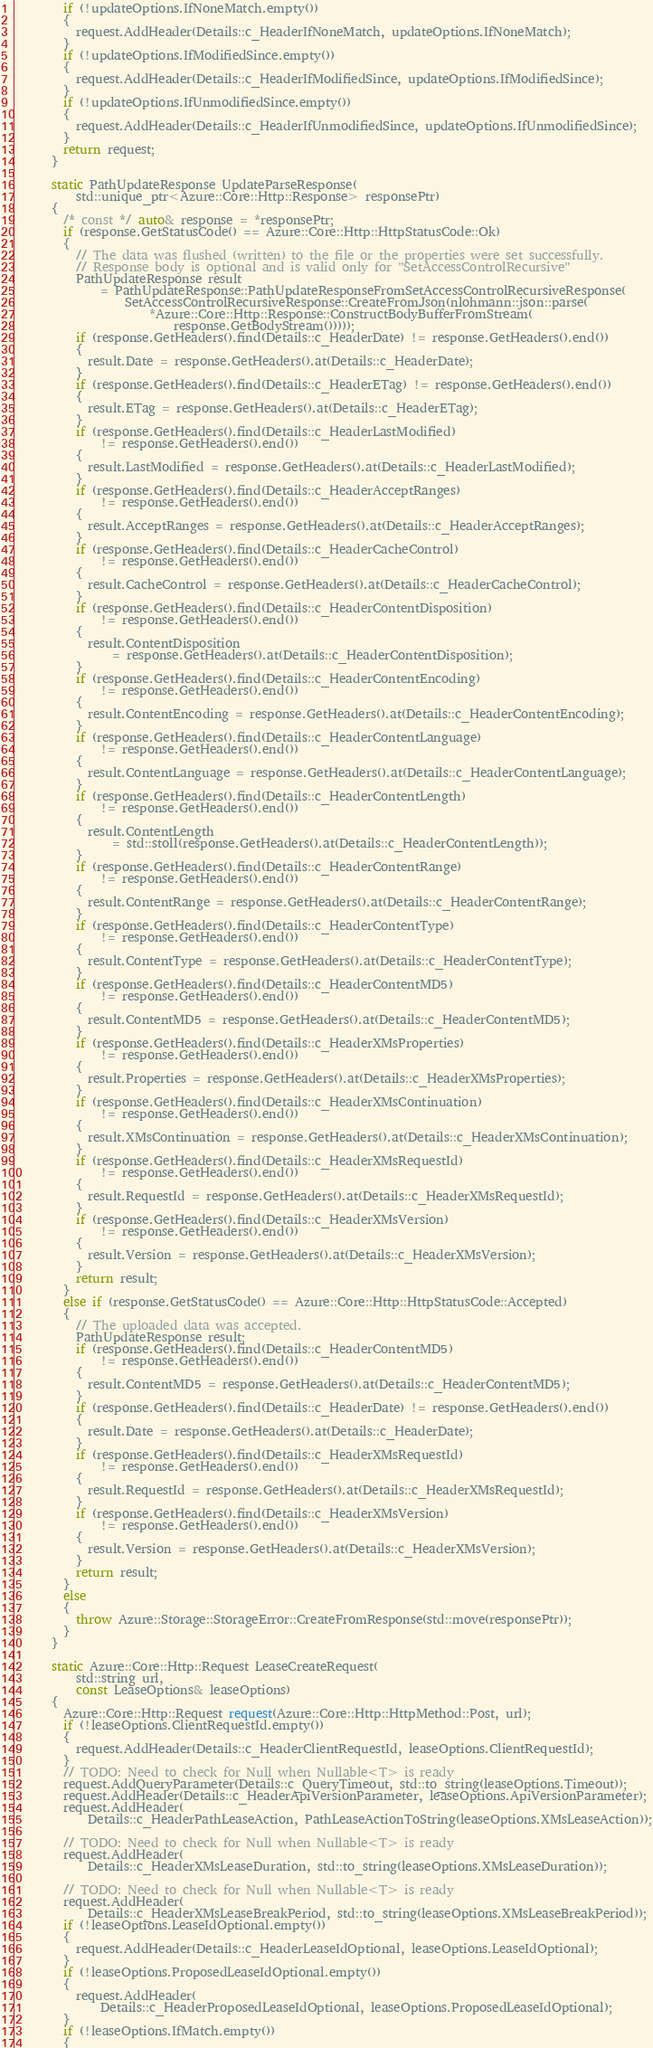<code> <loc_0><loc_0><loc_500><loc_500><_C++_>        if (!updateOptions.IfNoneMatch.empty())
        {
          request.AddHeader(Details::c_HeaderIfNoneMatch, updateOptions.IfNoneMatch);
        }
        if (!updateOptions.IfModifiedSince.empty())
        {
          request.AddHeader(Details::c_HeaderIfModifiedSince, updateOptions.IfModifiedSince);
        }
        if (!updateOptions.IfUnmodifiedSince.empty())
        {
          request.AddHeader(Details::c_HeaderIfUnmodifiedSince, updateOptions.IfUnmodifiedSince);
        }
        return request;
      }

      static PathUpdateResponse UpdateParseResponse(
          std::unique_ptr<Azure::Core::Http::Response> responsePtr)
      {
        /* const */ auto& response = *responsePtr;
        if (response.GetStatusCode() == Azure::Core::Http::HttpStatusCode::Ok)
        {
          // The data was flushed (written) to the file or the properties were set successfully.
          // Response body is optional and is valid only for "SetAccessControlRecursive"
          PathUpdateResponse result
              = PathUpdateResponse::PathUpdateResponseFromSetAccessControlRecursiveResponse(
                  SetAccessControlRecursiveResponse::CreateFromJson(nlohmann::json::parse(
                      *Azure::Core::Http::Response::ConstructBodyBufferFromStream(
                          response.GetBodyStream()))));
          if (response.GetHeaders().find(Details::c_HeaderDate) != response.GetHeaders().end())
          {
            result.Date = response.GetHeaders().at(Details::c_HeaderDate);
          }
          if (response.GetHeaders().find(Details::c_HeaderETag) != response.GetHeaders().end())
          {
            result.ETag = response.GetHeaders().at(Details::c_HeaderETag);
          }
          if (response.GetHeaders().find(Details::c_HeaderLastModified)
              != response.GetHeaders().end())
          {
            result.LastModified = response.GetHeaders().at(Details::c_HeaderLastModified);
          }
          if (response.GetHeaders().find(Details::c_HeaderAcceptRanges)
              != response.GetHeaders().end())
          {
            result.AcceptRanges = response.GetHeaders().at(Details::c_HeaderAcceptRanges);
          }
          if (response.GetHeaders().find(Details::c_HeaderCacheControl)
              != response.GetHeaders().end())
          {
            result.CacheControl = response.GetHeaders().at(Details::c_HeaderCacheControl);
          }
          if (response.GetHeaders().find(Details::c_HeaderContentDisposition)
              != response.GetHeaders().end())
          {
            result.ContentDisposition
                = response.GetHeaders().at(Details::c_HeaderContentDisposition);
          }
          if (response.GetHeaders().find(Details::c_HeaderContentEncoding)
              != response.GetHeaders().end())
          {
            result.ContentEncoding = response.GetHeaders().at(Details::c_HeaderContentEncoding);
          }
          if (response.GetHeaders().find(Details::c_HeaderContentLanguage)
              != response.GetHeaders().end())
          {
            result.ContentLanguage = response.GetHeaders().at(Details::c_HeaderContentLanguage);
          }
          if (response.GetHeaders().find(Details::c_HeaderContentLength)
              != response.GetHeaders().end())
          {
            result.ContentLength
                = std::stoll(response.GetHeaders().at(Details::c_HeaderContentLength));
          }
          if (response.GetHeaders().find(Details::c_HeaderContentRange)
              != response.GetHeaders().end())
          {
            result.ContentRange = response.GetHeaders().at(Details::c_HeaderContentRange);
          }
          if (response.GetHeaders().find(Details::c_HeaderContentType)
              != response.GetHeaders().end())
          {
            result.ContentType = response.GetHeaders().at(Details::c_HeaderContentType);
          }
          if (response.GetHeaders().find(Details::c_HeaderContentMD5)
              != response.GetHeaders().end())
          {
            result.ContentMD5 = response.GetHeaders().at(Details::c_HeaderContentMD5);
          }
          if (response.GetHeaders().find(Details::c_HeaderXMsProperties)
              != response.GetHeaders().end())
          {
            result.Properties = response.GetHeaders().at(Details::c_HeaderXMsProperties);
          }
          if (response.GetHeaders().find(Details::c_HeaderXMsContinuation)
              != response.GetHeaders().end())
          {
            result.XMsContinuation = response.GetHeaders().at(Details::c_HeaderXMsContinuation);
          }
          if (response.GetHeaders().find(Details::c_HeaderXMsRequestId)
              != response.GetHeaders().end())
          {
            result.RequestId = response.GetHeaders().at(Details::c_HeaderXMsRequestId);
          }
          if (response.GetHeaders().find(Details::c_HeaderXMsVersion)
              != response.GetHeaders().end())
          {
            result.Version = response.GetHeaders().at(Details::c_HeaderXMsVersion);
          }
          return result;
        }
        else if (response.GetStatusCode() == Azure::Core::Http::HttpStatusCode::Accepted)
        {
          // The uploaded data was accepted.
          PathUpdateResponse result;
          if (response.GetHeaders().find(Details::c_HeaderContentMD5)
              != response.GetHeaders().end())
          {
            result.ContentMD5 = response.GetHeaders().at(Details::c_HeaderContentMD5);
          }
          if (response.GetHeaders().find(Details::c_HeaderDate) != response.GetHeaders().end())
          {
            result.Date = response.GetHeaders().at(Details::c_HeaderDate);
          }
          if (response.GetHeaders().find(Details::c_HeaderXMsRequestId)
              != response.GetHeaders().end())
          {
            result.RequestId = response.GetHeaders().at(Details::c_HeaderXMsRequestId);
          }
          if (response.GetHeaders().find(Details::c_HeaderXMsVersion)
              != response.GetHeaders().end())
          {
            result.Version = response.GetHeaders().at(Details::c_HeaderXMsVersion);
          }
          return result;
        }
        else
        {
          throw Azure::Storage::StorageError::CreateFromResponse(std::move(responsePtr));
        }
      }

      static Azure::Core::Http::Request LeaseCreateRequest(
          std::string url,
          const LeaseOptions& leaseOptions)
      {
        Azure::Core::Http::Request request(Azure::Core::Http::HttpMethod::Post, url);
        if (!leaseOptions.ClientRequestId.empty())
        {
          request.AddHeader(Details::c_HeaderClientRequestId, leaseOptions.ClientRequestId);
        }
        // TODO: Need to check for Null when Nullable<T> is ready
        request.AddQueryParameter(Details::c_QueryTimeout, std::to_string(leaseOptions.Timeout));
        request.AddHeader(Details::c_HeaderApiVersionParameter, leaseOptions.ApiVersionParameter);
        request.AddHeader(
            Details::c_HeaderPathLeaseAction, PathLeaseActionToString(leaseOptions.XMsLeaseAction));

        // TODO: Need to check for Null when Nullable<T> is ready
        request.AddHeader(
            Details::c_HeaderXMsLeaseDuration, std::to_string(leaseOptions.XMsLeaseDuration));

        // TODO: Need to check for Null when Nullable<T> is ready
        request.AddHeader(
            Details::c_HeaderXMsLeaseBreakPeriod, std::to_string(leaseOptions.XMsLeaseBreakPeriod));
        if (!leaseOptions.LeaseIdOptional.empty())
        {
          request.AddHeader(Details::c_HeaderLeaseIdOptional, leaseOptions.LeaseIdOptional);
        }
        if (!leaseOptions.ProposedLeaseIdOptional.empty())
        {
          request.AddHeader(
              Details::c_HeaderProposedLeaseIdOptional, leaseOptions.ProposedLeaseIdOptional);
        }
        if (!leaseOptions.IfMatch.empty())
        {</code> 